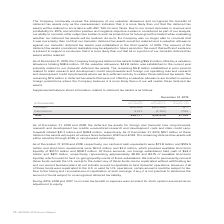According to Adtran's financial document, What does the table show? Supplemental balance sheet information related to deferred tax assets. The document states: "Supplemental balance sheet information related to deferred tax assets is as follows:..." Also, What was the company's International deferred tax assets? According to the financial document, 9,911 (in thousands). The relevant text states: "International 9,911 (2,350) 7,561..." Also, What was the company's domestic deferred tax assets? According to the financial document, $46,266 (in thousands). The relevant text states: "Domestic $46,266 $(46,266) $ —..." Also, can you calculate: What was the difference between domestic and international deferred tax assets? Based on the calculation: $46,266-9,911, the result is 36355 (in thousands). This is based on the information: "International 9,911 (2,350) 7,561 Domestic $46,266 $(46,266) $ —..." The key data points involved are: 46,266, 9,911. Also, can you calculate: What is the total Deferred Tax Assets, net expressed as a ratio to total Deferred Tax Assets? Based on the calculation: 7,561/56,177, the result is 0.13. This is based on the information: "Total $56,177 $(48,616) $7,561 Total $56,177 $(48,616) $7,561..." The key data points involved are: 56,177, 7,561. Also, can you calculate: What was domestic deferred tax assets as a percentage of the total deferred tax assets? Based on the calculation: $46,266/$56,177, the result is 82.36 (percentage). This is based on the information: "Total $56,177 $(48,616) $7,561 Domestic $46,266 $(46,266) $ —..." The key data points involved are: 46,266, 56,177. 